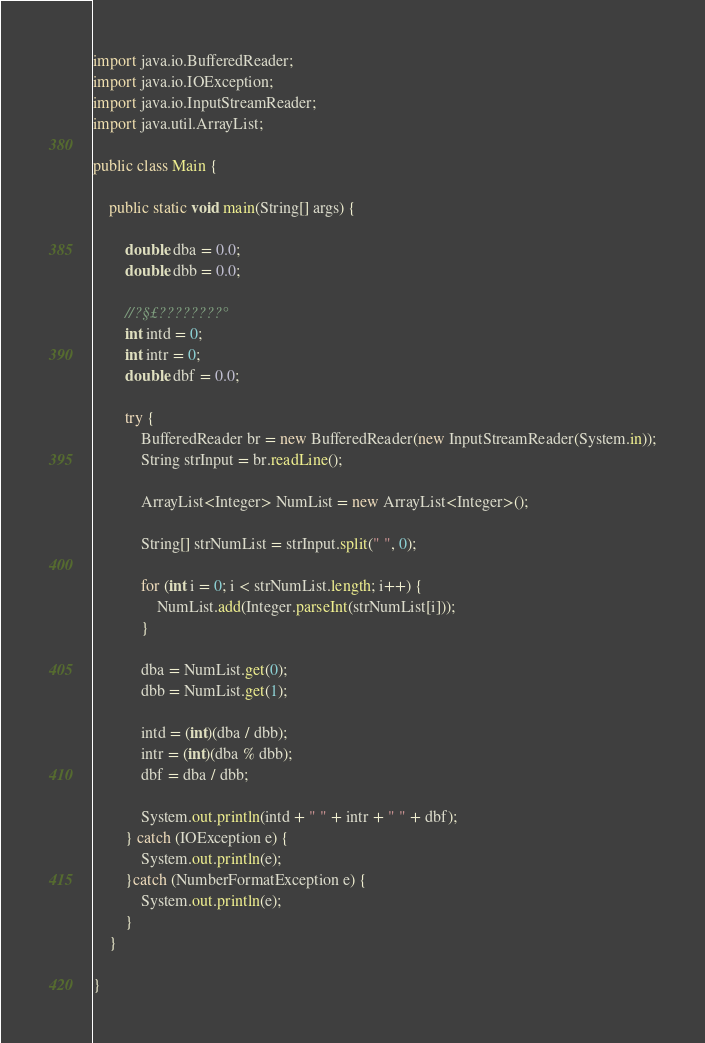Convert code to text. <code><loc_0><loc_0><loc_500><loc_500><_Java_>import java.io.BufferedReader;
import java.io.IOException;
import java.io.InputStreamReader;
import java.util.ArrayList;

public class Main {

	public static void main(String[] args) {

		double dba = 0.0;
		double dbb = 0.0;

		//?§£????????°
		int intd = 0;
		int intr = 0;
		double dbf = 0.0;

		try {
			BufferedReader br = new BufferedReader(new InputStreamReader(System.in));
			String strInput = br.readLine();

			ArrayList<Integer> NumList = new ArrayList<Integer>();

			String[] strNumList = strInput.split(" ", 0);

			for (int i = 0; i < strNumList.length; i++) {
				NumList.add(Integer.parseInt(strNumList[i]));
			}

			dba = NumList.get(0);
			dbb = NumList.get(1);

			intd = (int)(dba / dbb);
			intr = (int)(dba % dbb);
			dbf = dba / dbb;

			System.out.println(intd + " " + intr + " " + dbf);
		} catch (IOException e) {
			System.out.println(e);
		}catch (NumberFormatException e) {
			System.out.println(e);
		}
	}

}</code> 